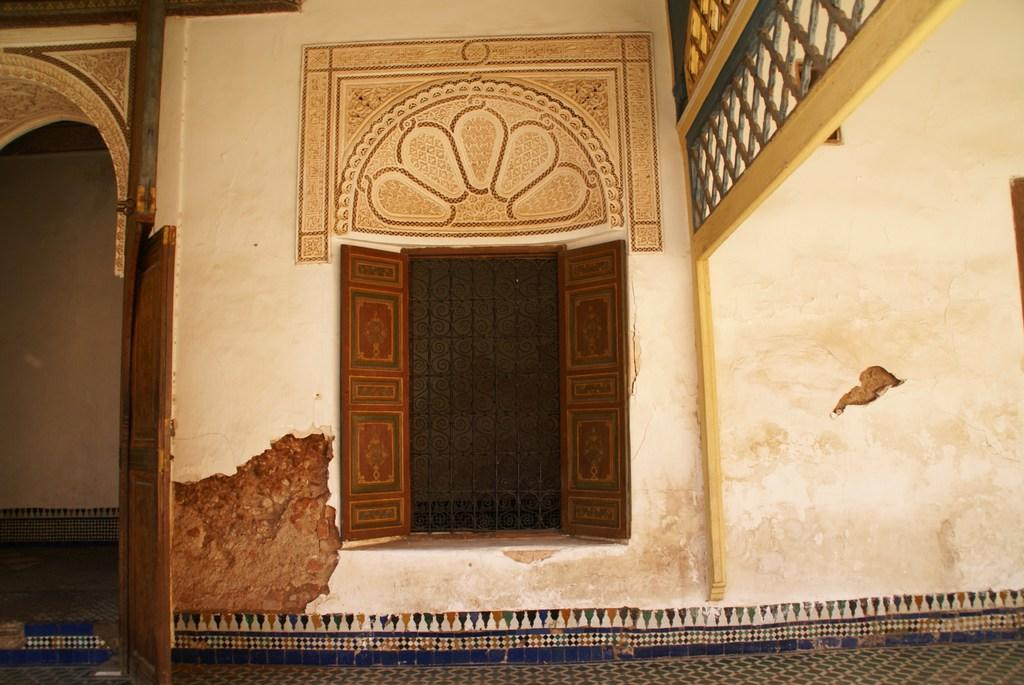What type of surface is visible in the image? There is a floor in the image. What can be seen in the image that allows light and air to enter the space? There is a window in the image. What are the openings in the image that can be used for entering or exiting a room? There are doors in the image. What type of material is present in the image that allows for ventilation or visibility? There is mesh in the image. What design elements can be seen on the walls in the image? There are walls with designs in the image. What type of pancake is being cooked on the floor in the image? There is no pancake present in the image; it only features a floor, window, doors, mesh, and walls with designs. 